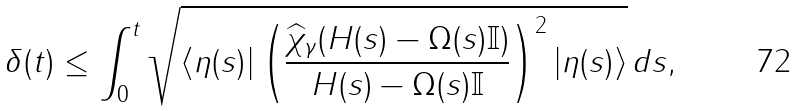Convert formula to latex. <formula><loc_0><loc_0><loc_500><loc_500>\delta ( t ) \leq \int _ { 0 } ^ { t } \sqrt { \langle \eta ( s ) | \left ( \frac { \widehat { \chi } _ { \gamma } ( H ( s ) - \Omega ( s ) \mathbb { I } ) } { H ( s ) - \Omega ( s ) \mathbb { I } } \right ) ^ { 2 } | \eta ( s ) \rangle } \, d s ,</formula> 